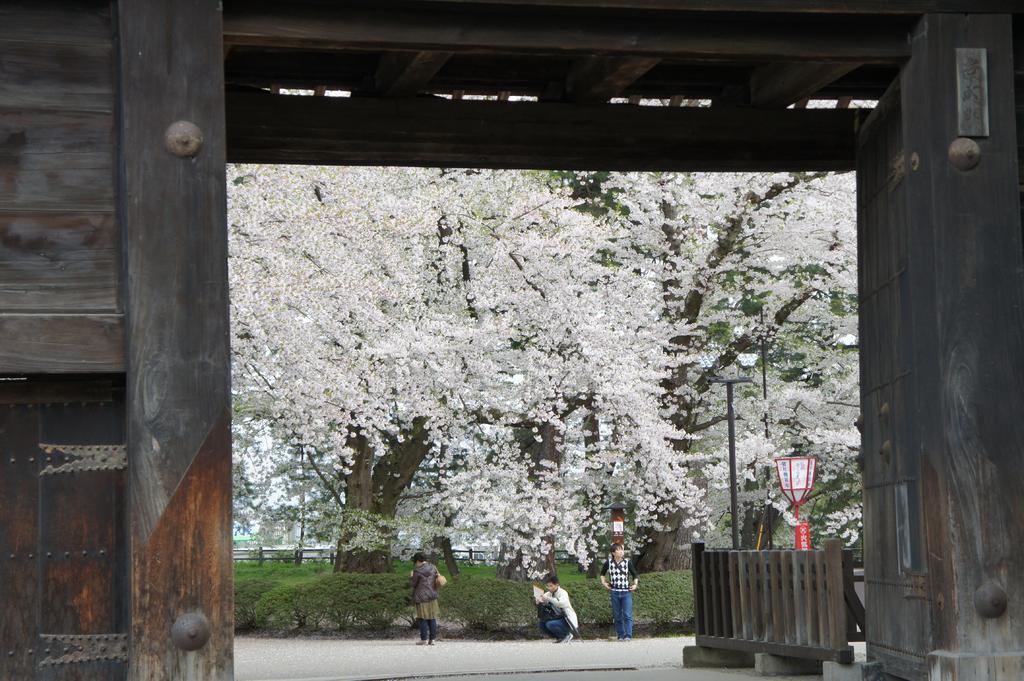In one or two sentences, can you explain what this image depicts? In the center of the image there are trees. There are persons. There is road. There is grass. 